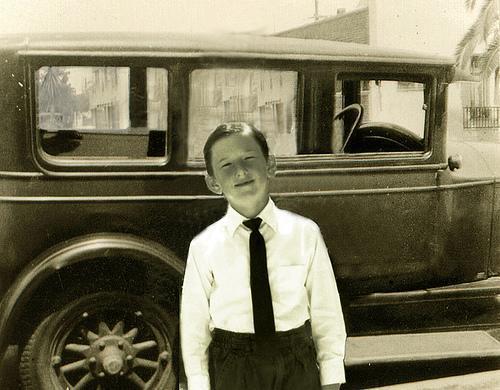How many trucks are on the road?
Give a very brief answer. 0. 